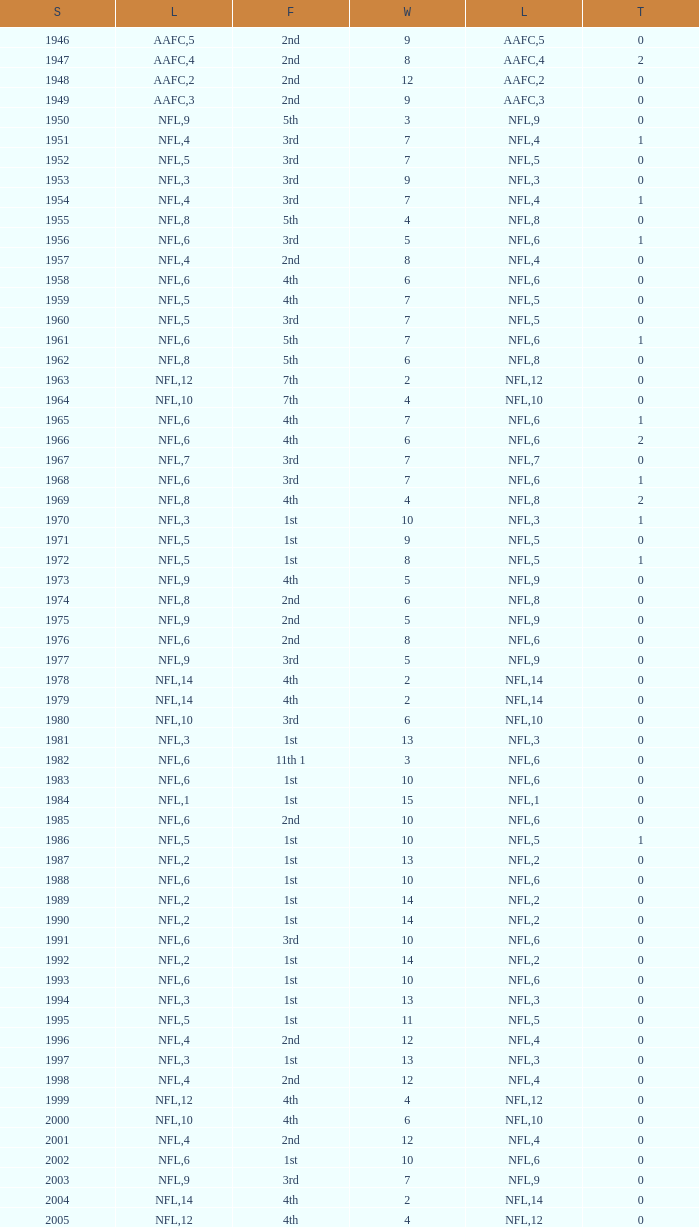What league had a finish of 2nd and 3 losses? AAFC. Can you parse all the data within this table? {'header': ['S', 'L', 'F', 'W', 'L', 'T'], 'rows': [['1946', 'AAFC', '2nd', '9', '5', '0'], ['1947', 'AAFC', '2nd', '8', '4', '2'], ['1948', 'AAFC', '2nd', '12', '2', '0'], ['1949', 'AAFC', '2nd', '9', '3', '0'], ['1950', 'NFL', '5th', '3', '9', '0'], ['1951', 'NFL', '3rd', '7', '4', '1'], ['1952', 'NFL', '3rd', '7', '5', '0'], ['1953', 'NFL', '3rd', '9', '3', '0'], ['1954', 'NFL', '3rd', '7', '4', '1'], ['1955', 'NFL', '5th', '4', '8', '0'], ['1956', 'NFL', '3rd', '5', '6', '1'], ['1957', 'NFL', '2nd', '8', '4', '0'], ['1958', 'NFL', '4th', '6', '6', '0'], ['1959', 'NFL', '4th', '7', '5', '0'], ['1960', 'NFL', '3rd', '7', '5', '0'], ['1961', 'NFL', '5th', '7', '6', '1'], ['1962', 'NFL', '5th', '6', '8', '0'], ['1963', 'NFL', '7th', '2', '12', '0'], ['1964', 'NFL', '7th', '4', '10', '0'], ['1965', 'NFL', '4th', '7', '6', '1'], ['1966', 'NFL', '4th', '6', '6', '2'], ['1967', 'NFL', '3rd', '7', '7', '0'], ['1968', 'NFL', '3rd', '7', '6', '1'], ['1969', 'NFL', '4th', '4', '8', '2'], ['1970', 'NFL', '1st', '10', '3', '1'], ['1971', 'NFL', '1st', '9', '5', '0'], ['1972', 'NFL', '1st', '8', '5', '1'], ['1973', 'NFL', '4th', '5', '9', '0'], ['1974', 'NFL', '2nd', '6', '8', '0'], ['1975', 'NFL', '2nd', '5', '9', '0'], ['1976', 'NFL', '2nd', '8', '6', '0'], ['1977', 'NFL', '3rd', '5', '9', '0'], ['1978', 'NFL', '4th', '2', '14', '0'], ['1979', 'NFL', '4th', '2', '14', '0'], ['1980', 'NFL', '3rd', '6', '10', '0'], ['1981', 'NFL', '1st', '13', '3', '0'], ['1982', 'NFL', '11th 1', '3', '6', '0'], ['1983', 'NFL', '1st', '10', '6', '0'], ['1984', 'NFL', '1st', '15', '1', '0'], ['1985', 'NFL', '2nd', '10', '6', '0'], ['1986', 'NFL', '1st', '10', '5', '1'], ['1987', 'NFL', '1st', '13', '2', '0'], ['1988', 'NFL', '1st', '10', '6', '0'], ['1989', 'NFL', '1st', '14', '2', '0'], ['1990', 'NFL', '1st', '14', '2', '0'], ['1991', 'NFL', '3rd', '10', '6', '0'], ['1992', 'NFL', '1st', '14', '2', '0'], ['1993', 'NFL', '1st', '10', '6', '0'], ['1994', 'NFL', '1st', '13', '3', '0'], ['1995', 'NFL', '1st', '11', '5', '0'], ['1996', 'NFL', '2nd', '12', '4', '0'], ['1997', 'NFL', '1st', '13', '3', '0'], ['1998', 'NFL', '2nd', '12', '4', '0'], ['1999', 'NFL', '4th', '4', '12', '0'], ['2000', 'NFL', '4th', '6', '10', '0'], ['2001', 'NFL', '2nd', '12', '4', '0'], ['2002', 'NFL', '1st', '10', '6', '0'], ['2003', 'NFL', '3rd', '7', '9', '0'], ['2004', 'NFL', '4th', '2', '14', '0'], ['2005', 'NFL', '4th', '4', '12', '0'], ['2006', 'NFL', '3rd', '7', '9', '0'], ['2007', 'NFL', '3rd', '5', '11', '0'], ['2008', 'NFL', '2nd', '7', '9', '0'], ['2009', 'NFL', '2nd', '8', '8', '0'], ['2010', 'NFL', '3rd', '6', '10', '0'], ['2011', 'NFL', '1st', '13', '3', '0'], ['2012', 'NFL', '1st', '11', '4', '1'], ['2013', 'NFL', '2nd', '6', '2', '0']]} 